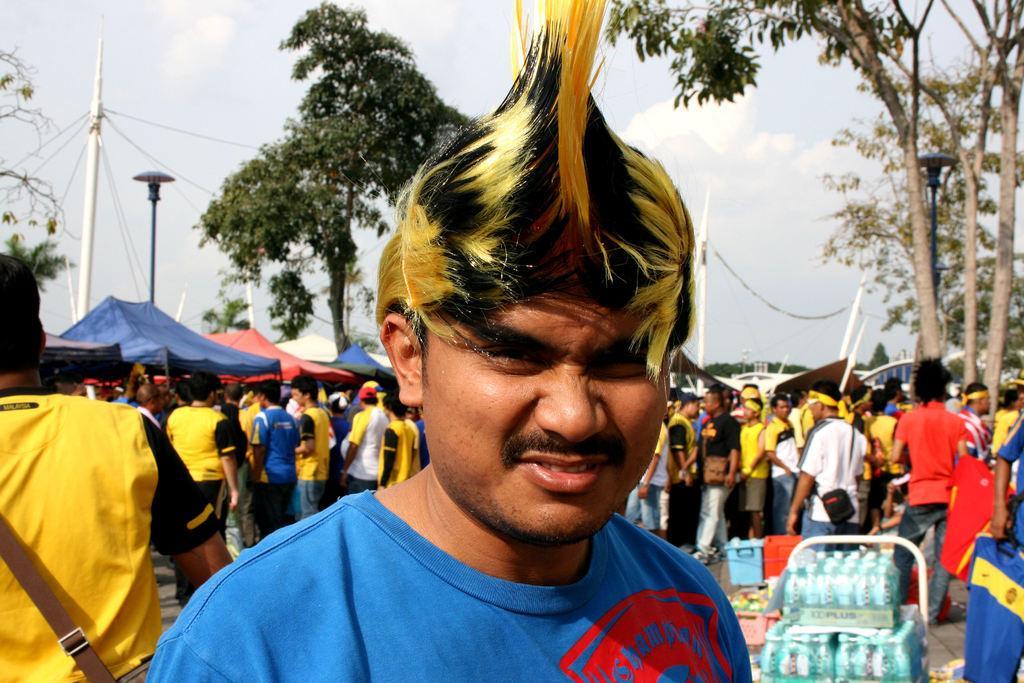How would you summarize this image in a sentence or two? In this image we can see a few people, one of them is holding a t-shirt, there are trees, boxes, tents, there are poles, ropes, also we can see the sky. 